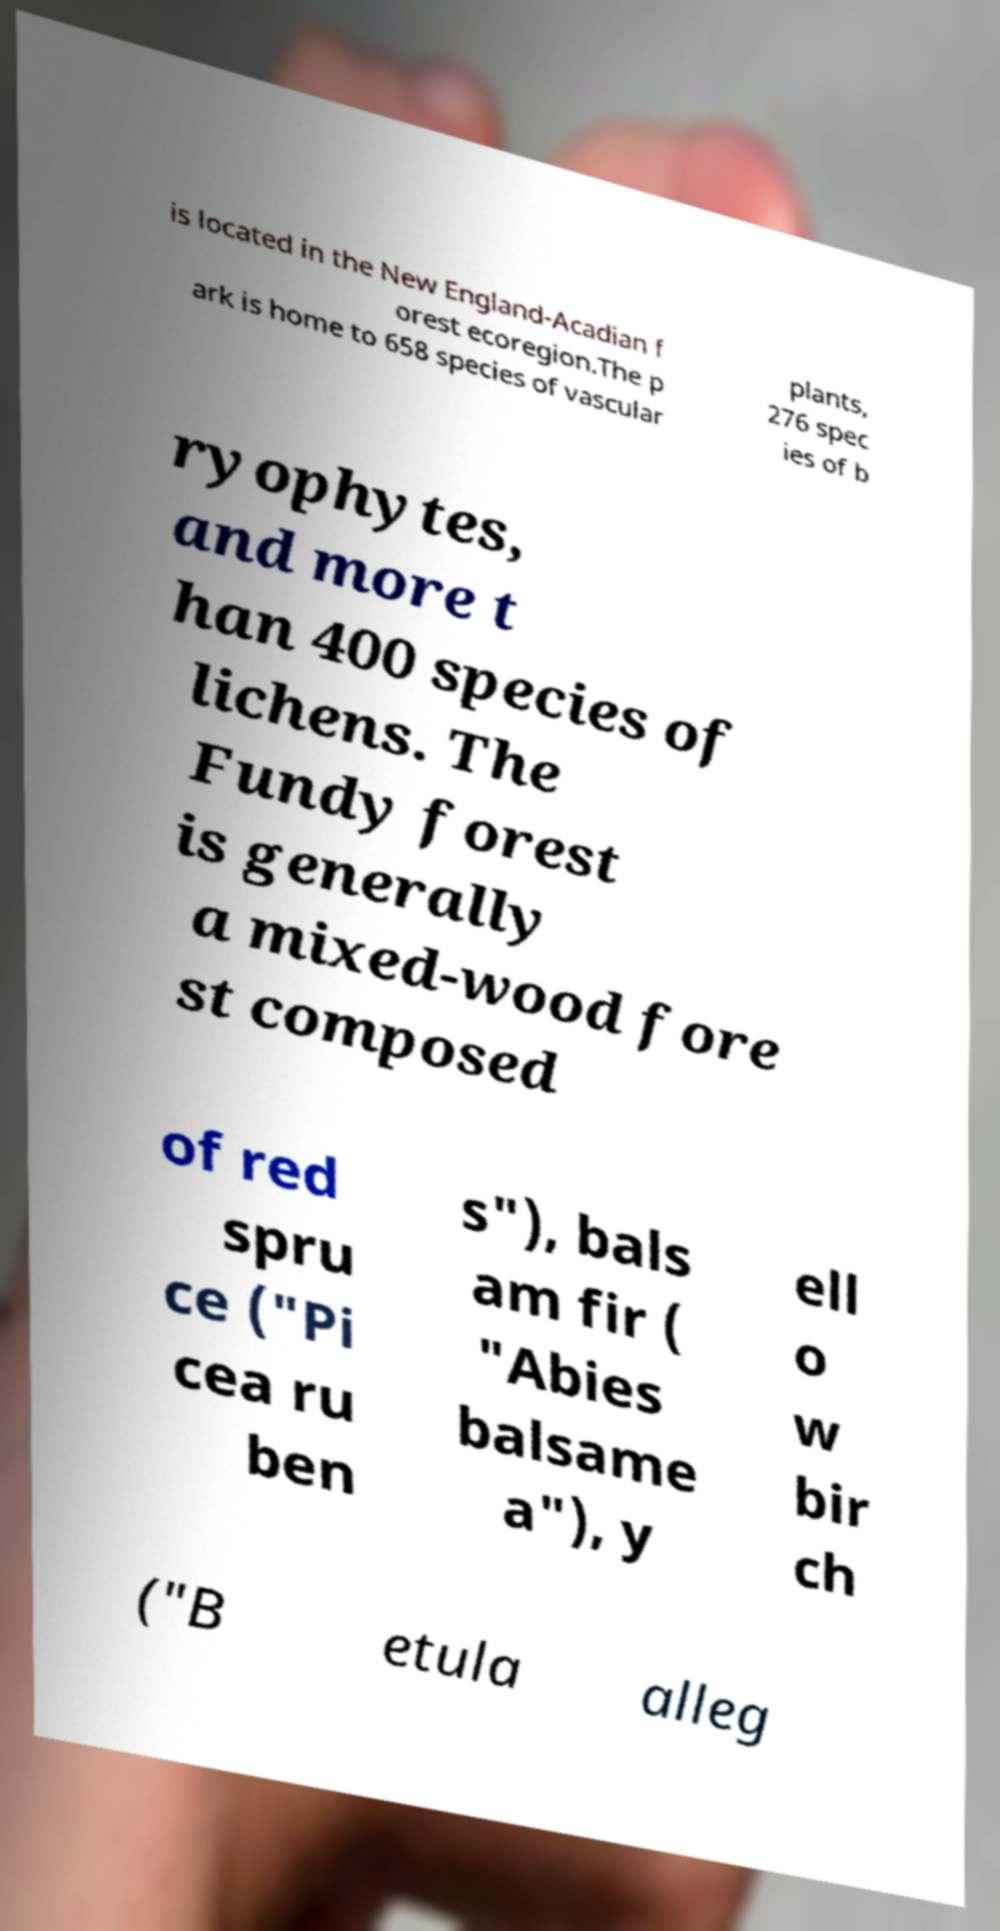Please identify and transcribe the text found in this image. is located in the New England-Acadian f orest ecoregion.The p ark is home to 658 species of vascular plants, 276 spec ies of b ryophytes, and more t han 400 species of lichens. The Fundy forest is generally a mixed-wood fore st composed of red spru ce ("Pi cea ru ben s"), bals am fir ( "Abies balsame a"), y ell o w bir ch ("B etula alleg 